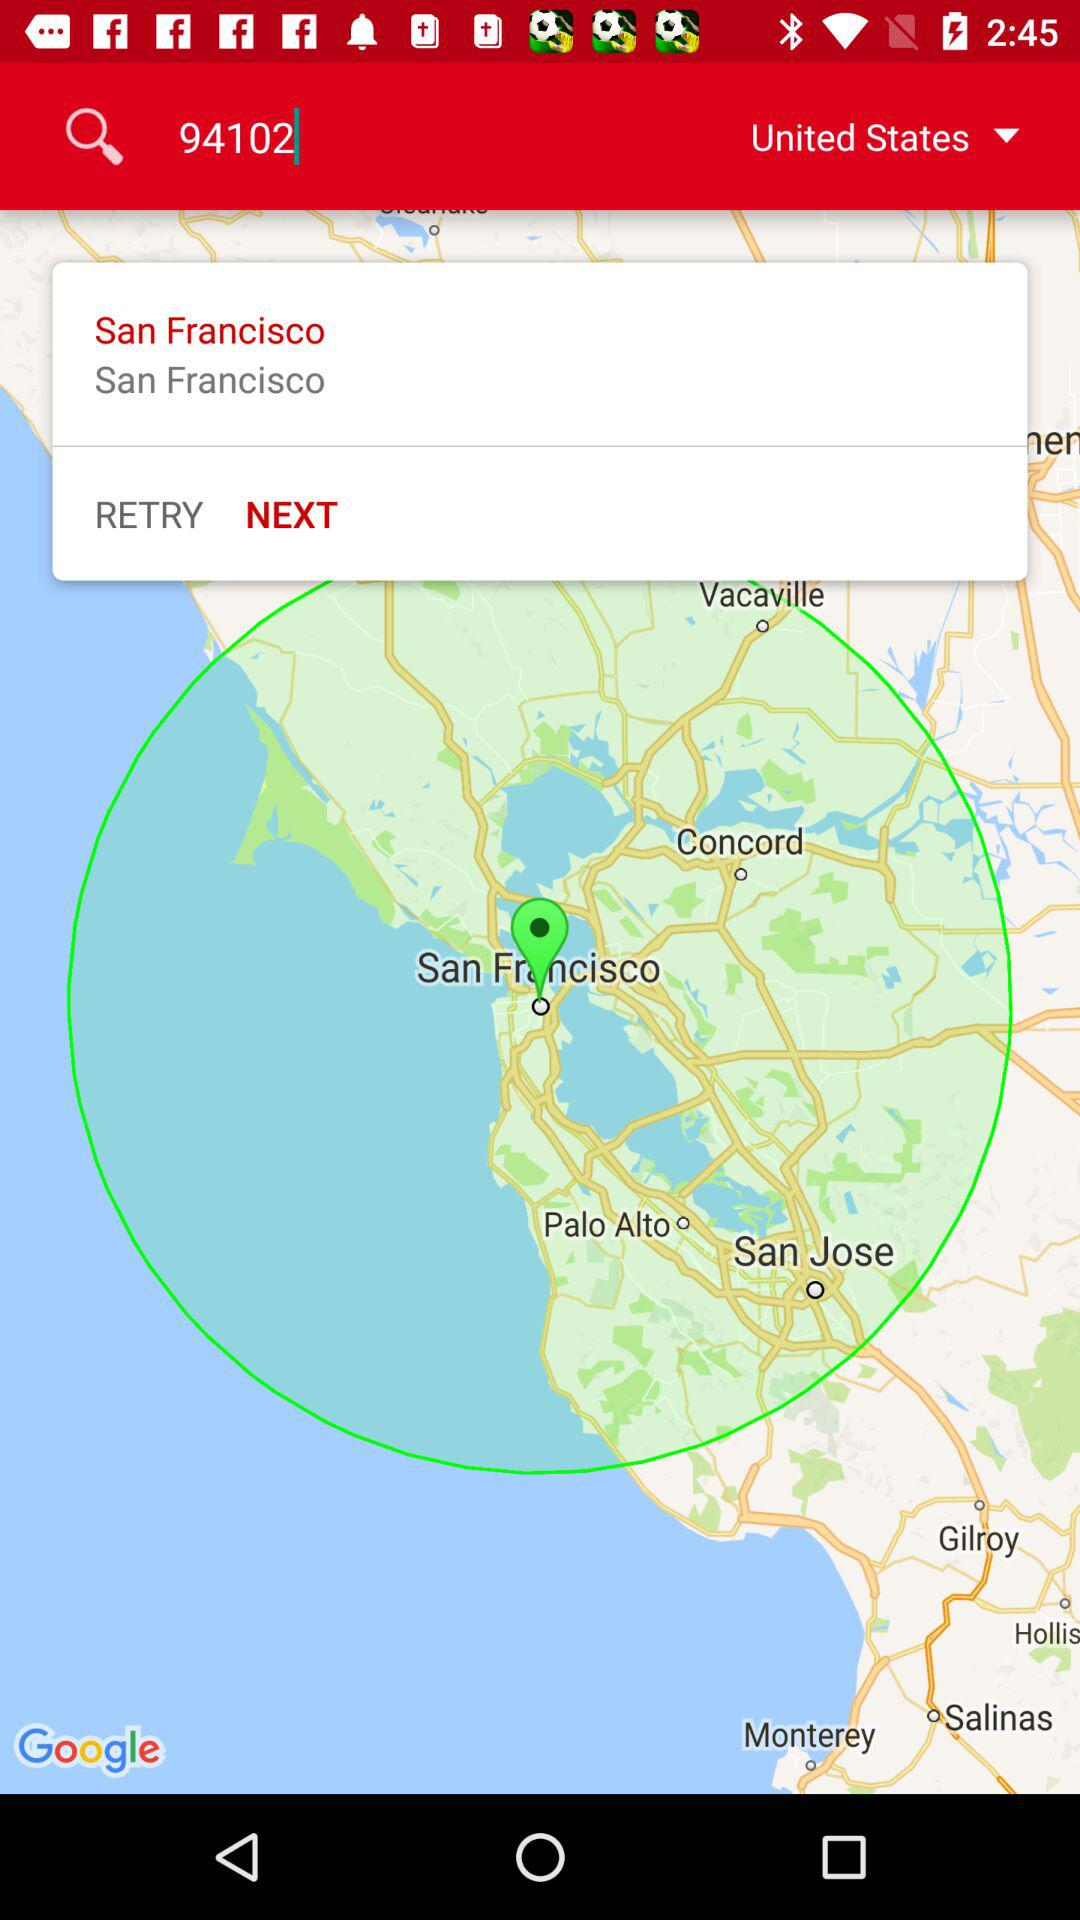In which country is San Francisco located? San Francisco is located in the United States. 